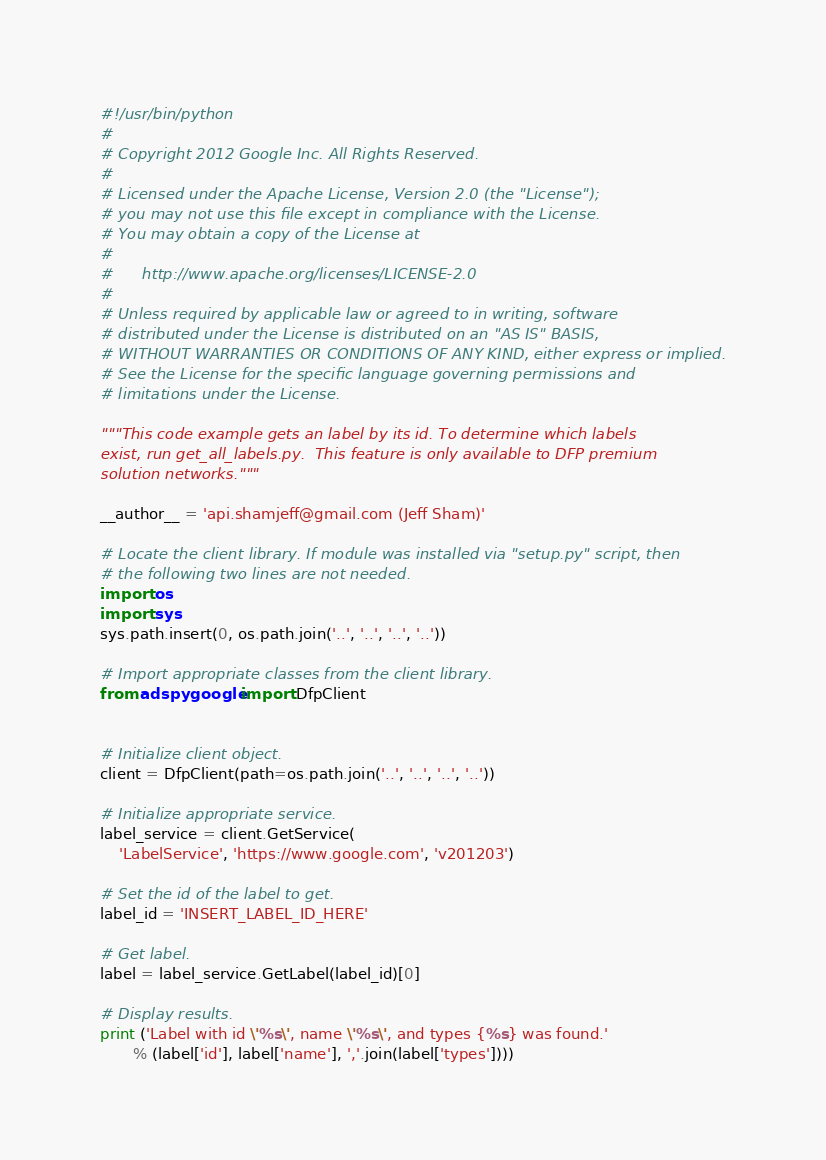Convert code to text. <code><loc_0><loc_0><loc_500><loc_500><_Python_>#!/usr/bin/python
#
# Copyright 2012 Google Inc. All Rights Reserved.
#
# Licensed under the Apache License, Version 2.0 (the "License");
# you may not use this file except in compliance with the License.
# You may obtain a copy of the License at
#
#      http://www.apache.org/licenses/LICENSE-2.0
#
# Unless required by applicable law or agreed to in writing, software
# distributed under the License is distributed on an "AS IS" BASIS,
# WITHOUT WARRANTIES OR CONDITIONS OF ANY KIND, either express or implied.
# See the License for the specific language governing permissions and
# limitations under the License.

"""This code example gets an label by its id. To determine which labels
exist, run get_all_labels.py.  This feature is only available to DFP premium
solution networks."""

__author__ = 'api.shamjeff@gmail.com (Jeff Sham)'

# Locate the client library. If module was installed via "setup.py" script, then
# the following two lines are not needed.
import os
import sys
sys.path.insert(0, os.path.join('..', '..', '..', '..'))

# Import appropriate classes from the client library.
from adspygoogle import DfpClient


# Initialize client object.
client = DfpClient(path=os.path.join('..', '..', '..', '..'))

# Initialize appropriate service.
label_service = client.GetService(
    'LabelService', 'https://www.google.com', 'v201203')

# Set the id of the label to get.
label_id = 'INSERT_LABEL_ID_HERE'

# Get label.
label = label_service.GetLabel(label_id)[0]

# Display results.
print ('Label with id \'%s\', name \'%s\', and types {%s} was found.'
       % (label['id'], label['name'], ','.join(label['types'])))
</code> 